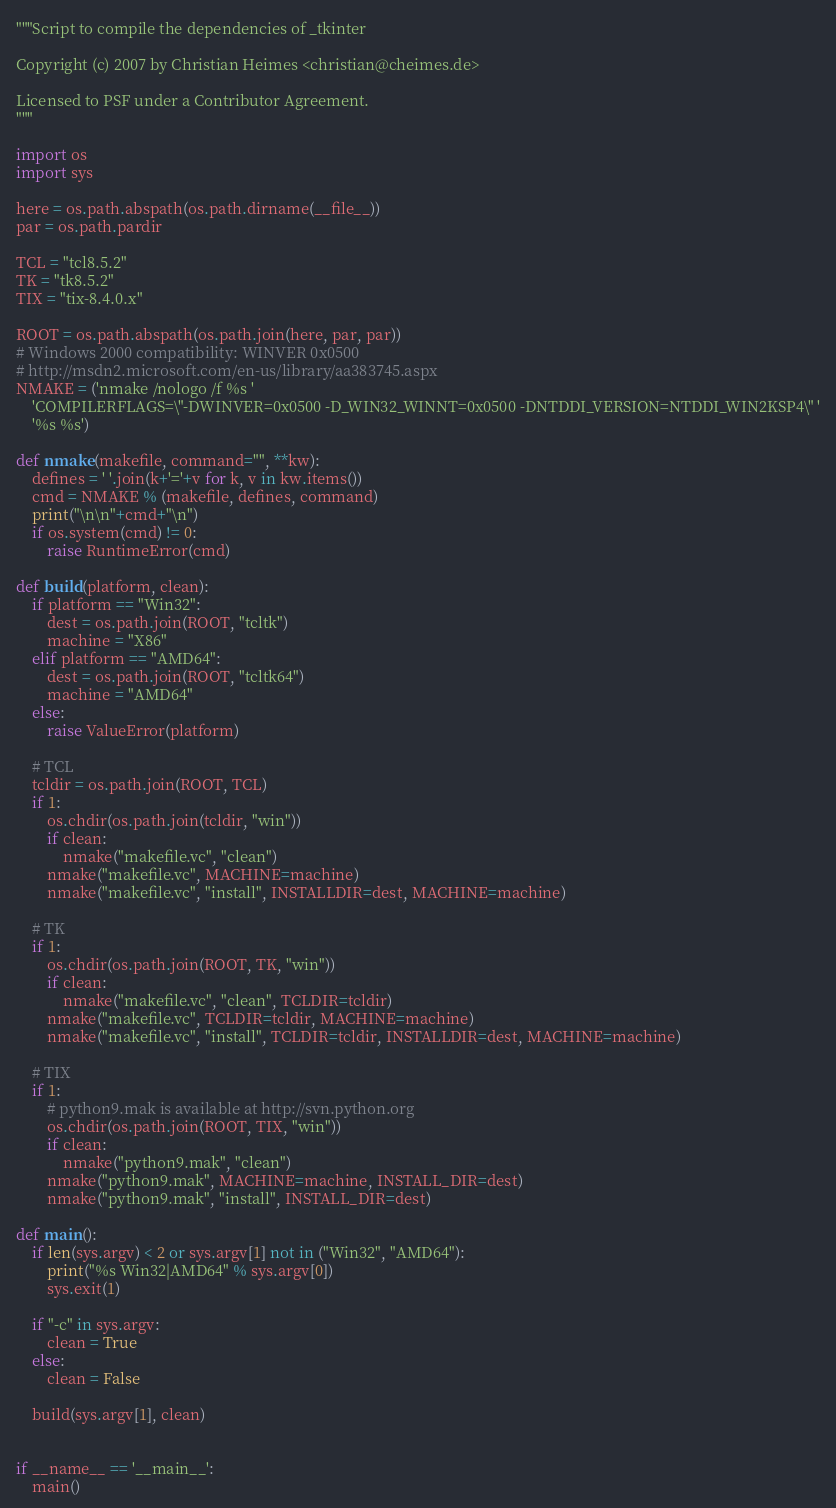<code> <loc_0><loc_0><loc_500><loc_500><_Python_>"""Script to compile the dependencies of _tkinter

Copyright (c) 2007 by Christian Heimes <christian@cheimes.de>

Licensed to PSF under a Contributor Agreement.
"""

import os
import sys

here = os.path.abspath(os.path.dirname(__file__))
par = os.path.pardir

TCL = "tcl8.5.2"
TK = "tk8.5.2"
TIX = "tix-8.4.0.x"

ROOT = os.path.abspath(os.path.join(here, par, par))
# Windows 2000 compatibility: WINVER 0x0500
# http://msdn2.microsoft.com/en-us/library/aa383745.aspx
NMAKE = ('nmake /nologo /f %s '
    'COMPILERFLAGS=\"-DWINVER=0x0500 -D_WIN32_WINNT=0x0500 -DNTDDI_VERSION=NTDDI_WIN2KSP4\" '
    '%s %s')

def nmake(makefile, command="", **kw):
    defines = ' '.join(k+'='+v for k, v in kw.items())
    cmd = NMAKE % (makefile, defines, command)
    print("\n\n"+cmd+"\n")
    if os.system(cmd) != 0:
        raise RuntimeError(cmd)

def build(platform, clean):
    if platform == "Win32":
        dest = os.path.join(ROOT, "tcltk")
        machine = "X86"
    elif platform == "AMD64":
        dest = os.path.join(ROOT, "tcltk64")
        machine = "AMD64"
    else:
        raise ValueError(platform)

    # TCL
    tcldir = os.path.join(ROOT, TCL)
    if 1:
        os.chdir(os.path.join(tcldir, "win"))
        if clean:
            nmake("makefile.vc", "clean")
        nmake("makefile.vc", MACHINE=machine)
        nmake("makefile.vc", "install", INSTALLDIR=dest, MACHINE=machine)

    # TK
    if 1:
        os.chdir(os.path.join(ROOT, TK, "win"))
        if clean:
            nmake("makefile.vc", "clean", TCLDIR=tcldir)
        nmake("makefile.vc", TCLDIR=tcldir, MACHINE=machine)
        nmake("makefile.vc", "install", TCLDIR=tcldir, INSTALLDIR=dest, MACHINE=machine)

    # TIX
    if 1:
        # python9.mak is available at http://svn.python.org
        os.chdir(os.path.join(ROOT, TIX, "win"))
        if clean:
            nmake("python9.mak", "clean")
        nmake("python9.mak", MACHINE=machine, INSTALL_DIR=dest)
        nmake("python9.mak", "install", INSTALL_DIR=dest)

def main():
    if len(sys.argv) < 2 or sys.argv[1] not in ("Win32", "AMD64"):
        print("%s Win32|AMD64" % sys.argv[0])
        sys.exit(1)

    if "-c" in sys.argv:
        clean = True
    else:
        clean = False

    build(sys.argv[1], clean)


if __name__ == '__main__':
    main()
</code> 